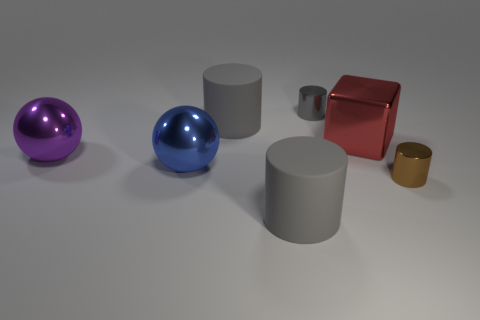There is a thing left of the blue metal sphere; does it have the same size as the big blue thing?
Your answer should be very brief. Yes. There is a matte thing that is in front of the large matte thing that is behind the large blue metallic object; are there any cylinders that are left of it?
Ensure brevity in your answer.  Yes. What number of metallic objects are either red objects or small purple blocks?
Make the answer very short. 1. What number of other things are the same shape as the big blue thing?
Offer a terse response. 1. Are there more purple spheres than big brown metallic things?
Your response must be concise. Yes. How big is the cube that is to the right of the tiny object behind the tiny brown metal cylinder in front of the blue thing?
Make the answer very short. Large. What size is the blue thing that is in front of the big red shiny object?
Give a very brief answer. Large. How many objects are either gray matte objects or big gray cylinders behind the small brown object?
Your answer should be very brief. 2. What number of other things are there of the same size as the metallic block?
Your answer should be compact. 4. There is a tiny gray thing that is the same shape as the tiny brown shiny thing; what is it made of?
Your response must be concise. Metal. 